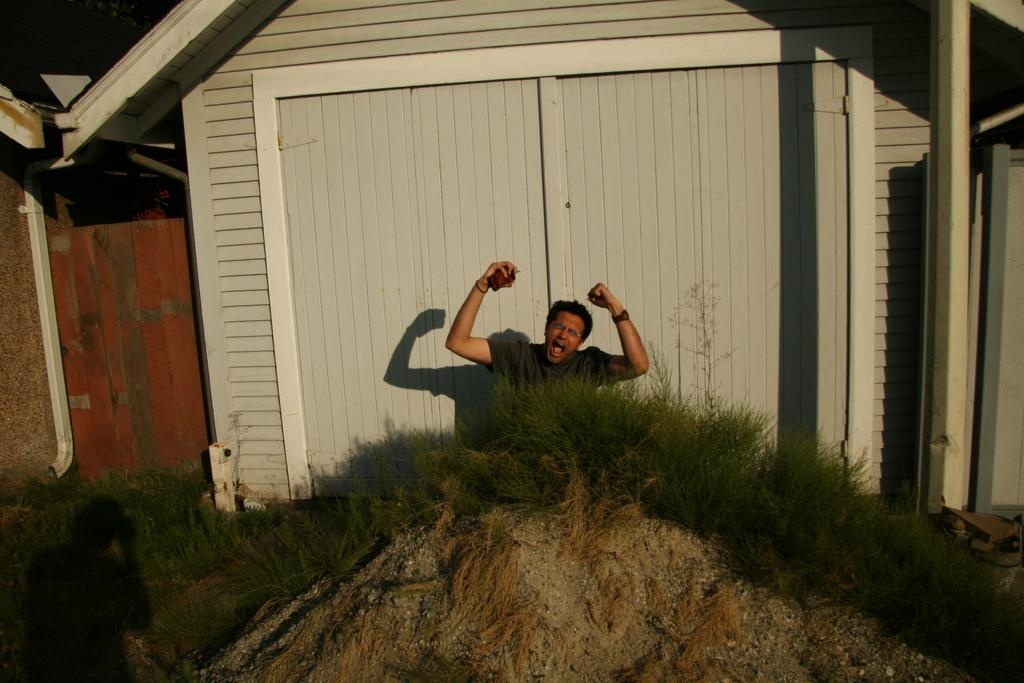What is the main subject of the image? There is a person sitting on the ground in the center of the image. What can be seen at the bottom of the image? The ground is visible at the bottom of the image, and grass is present there. What is visible in the background of the image? There are houses in the background of the image. What type of scarf is the person wearing in the image? There is no scarf visible in the image; the person is sitting on the ground without any visible accessories. 